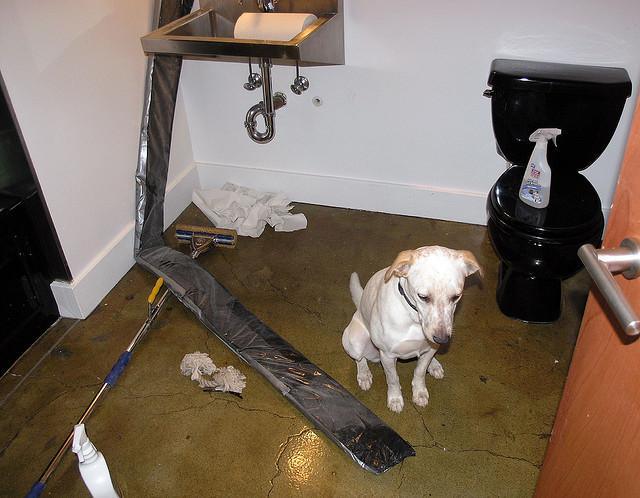What color is the dog?
Short answer required. White. Is there a mop on the floor?
Answer briefly. Yes. What did the dog do?
Write a very short answer. Mess. 